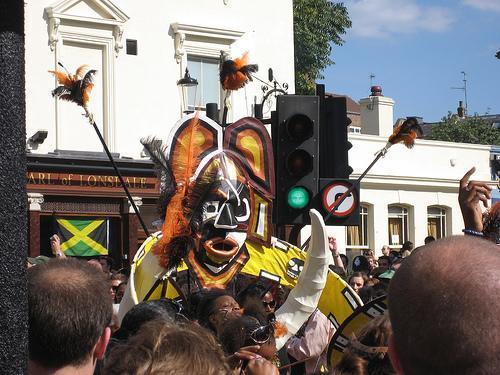How many lights can be seen on the traffic signal?
Give a very brief answer. 3. How many masks are in the picture?
Give a very brief answer. 1. 